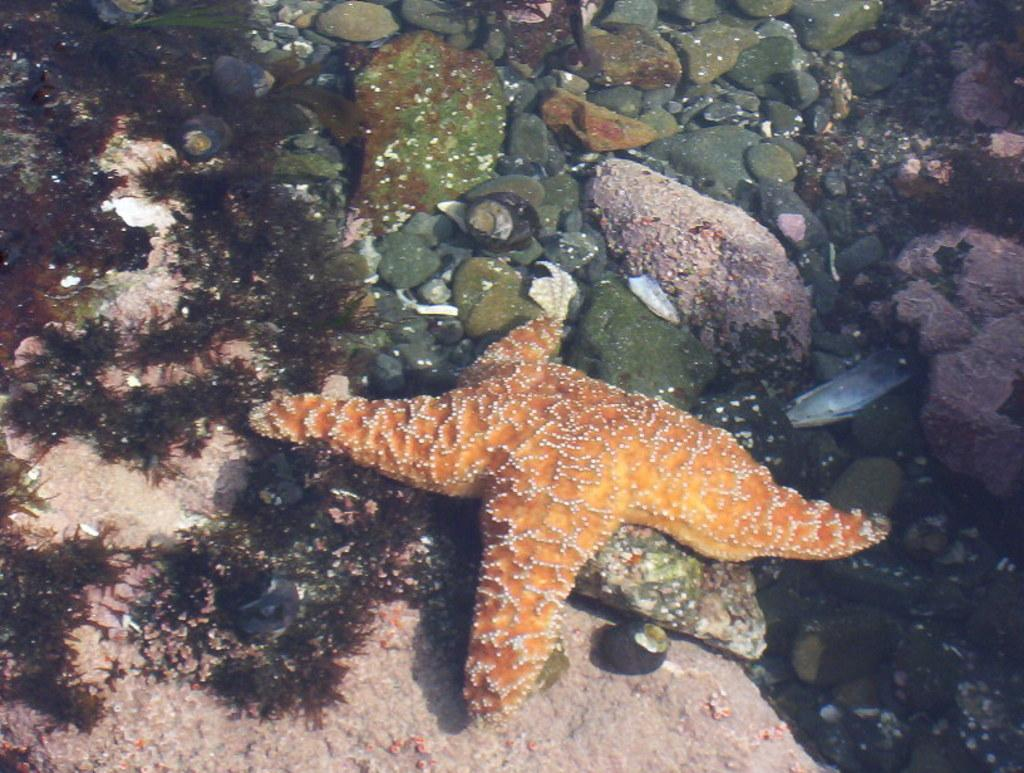What type of environment is shown in the image? The image depicts an underwater environment. What marine creature can be seen in the front of the image? There is a starfish in the front of the image. What can be seen in the background of the image? There are stones visible in the background of the image. Where is the stamp drawer located in the image? There is no stamp drawer present in the image, as it depicts an underwater environment. 